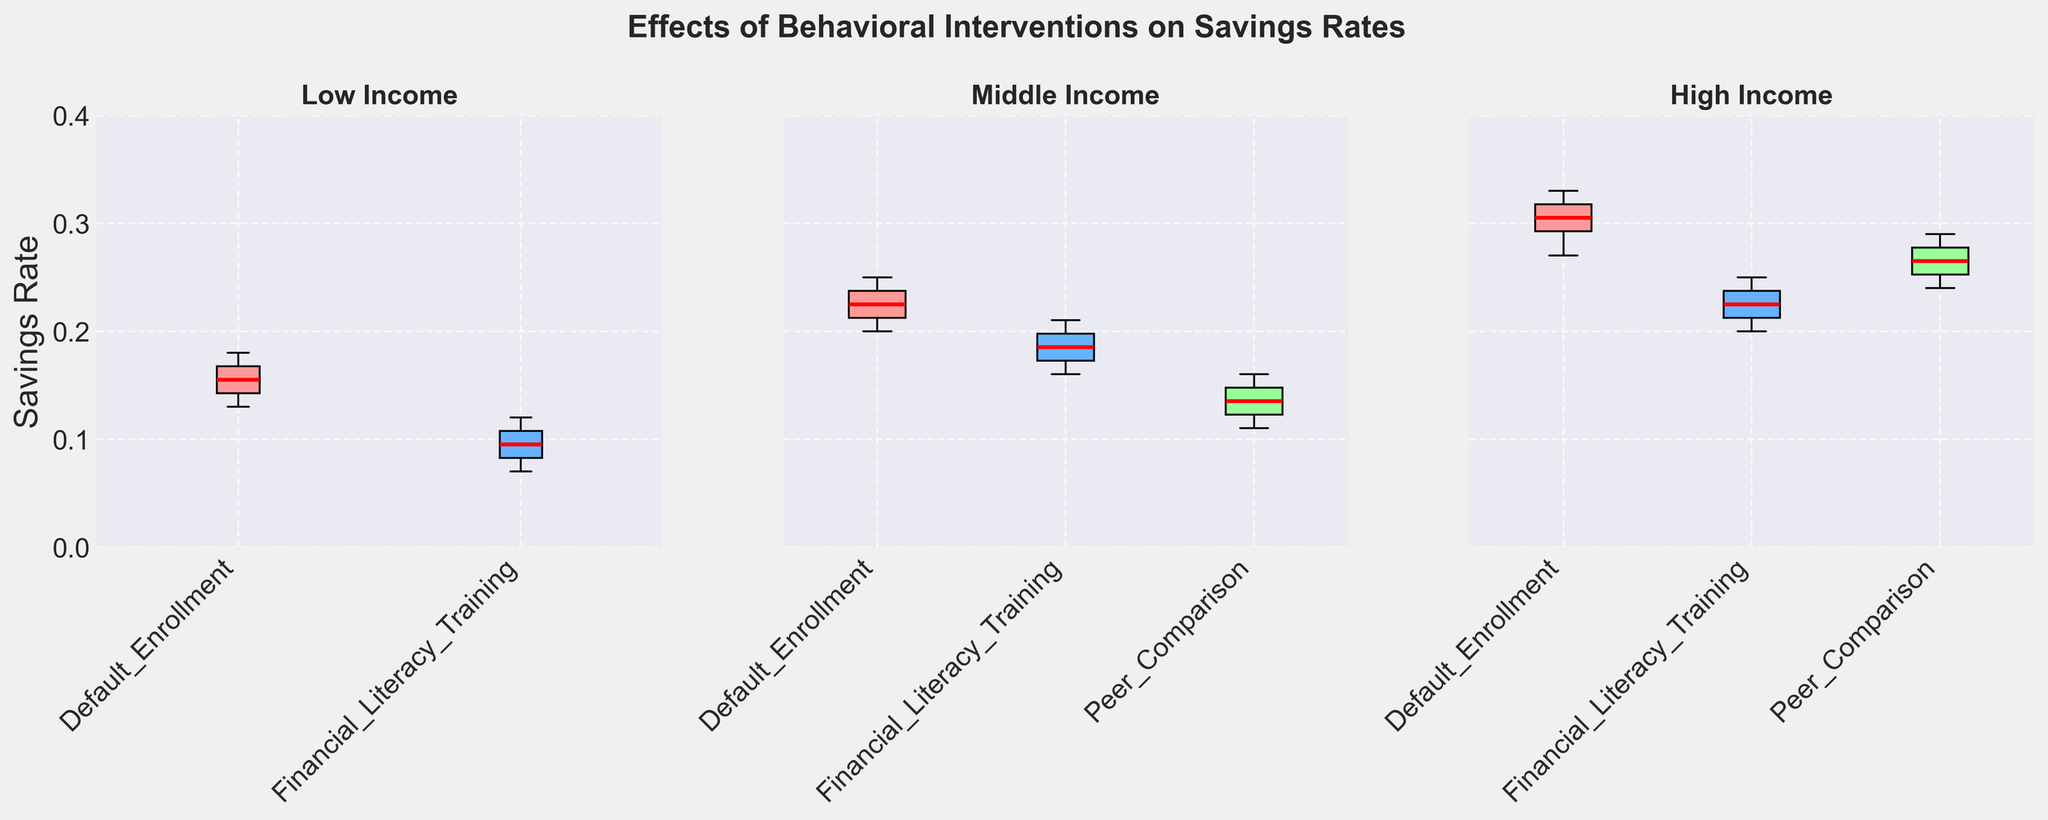Which income group has the highest median savings rate for the Default Enrollment intervention? By looking at the three subplots, for the Default Enrollment intervention, the High-income group has the highest median savings rate (marked by the red line in the box plot).
Answer: High In the Middle-income group, which intervention has the lowest median savings rate and what is it? Check the red median lines in the Middle-income subplot. The Peer Comparison intervention has the lowest median savings rate.
Answer: Peer Comparison How does the median savings rate for Financial Literacy Training compare between the Low and High-income groups? Compare the median values (red lines) for Financial Literacy Training in the Low and High-income subplots. The Low-income group has a lower median savings rate than the High-income group.
Answer: Lower What is the range of savings rates in the Low-income group for the Default Enrollment intervention? In the Low-income subplot, the Default Enrollment intervention's box plot's lower whisker represents the minimum (0.13), and the upper whisker represents the maximum (0.18). The range is 0.18 - 0.13.
Answer: 0.05 Which intervention shows the smallest variability in savings rates for the High-income group? The smallest variability can be determined by the length of the box and whiskers. For the High-income group, Financial Literacy Training shows the smallest variability.
Answer: Financial Literacy Training Is the median savings rate for Financial Literacy Training in the Middle-income group higher than the 75th percentile of the Low-income group for Default Enrollment? Compare the median value (red line) of Financial Literacy Training in the Middle-income subplot to the top edge of the box (75th percentile) for Default Enrollment in the Low-income subplot. The median value (around 0.18-0.19) is higher than the 75th percentile (0.17).
Answer: Yes What is the interquartile range (IQR) for the Peer Comparison intervention in the Middle-income group? The IQR is the difference between the 75th percentile and the 25th percentile. For Peer Comparison in the Middle-income group, this is 0.15 (top of box) - 0.12 (bottom of box).
Answer: 0.03 Among the income groups, which intervention consistently shows a higher savings rate compared to Peer Comparison? Look at each subplot and compare Peer Comparison to other interventions. Default Enrollment consistently shows a higher savings rate compared to Peer Comparison across all income groups.
Answer: Default Enrollment 